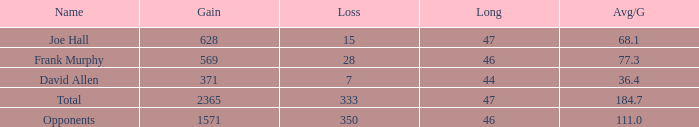Which Avg/G is the lowest one that has a Long smaller than 47, and a Name of frank murphy, and a Gain smaller than 569? None. 